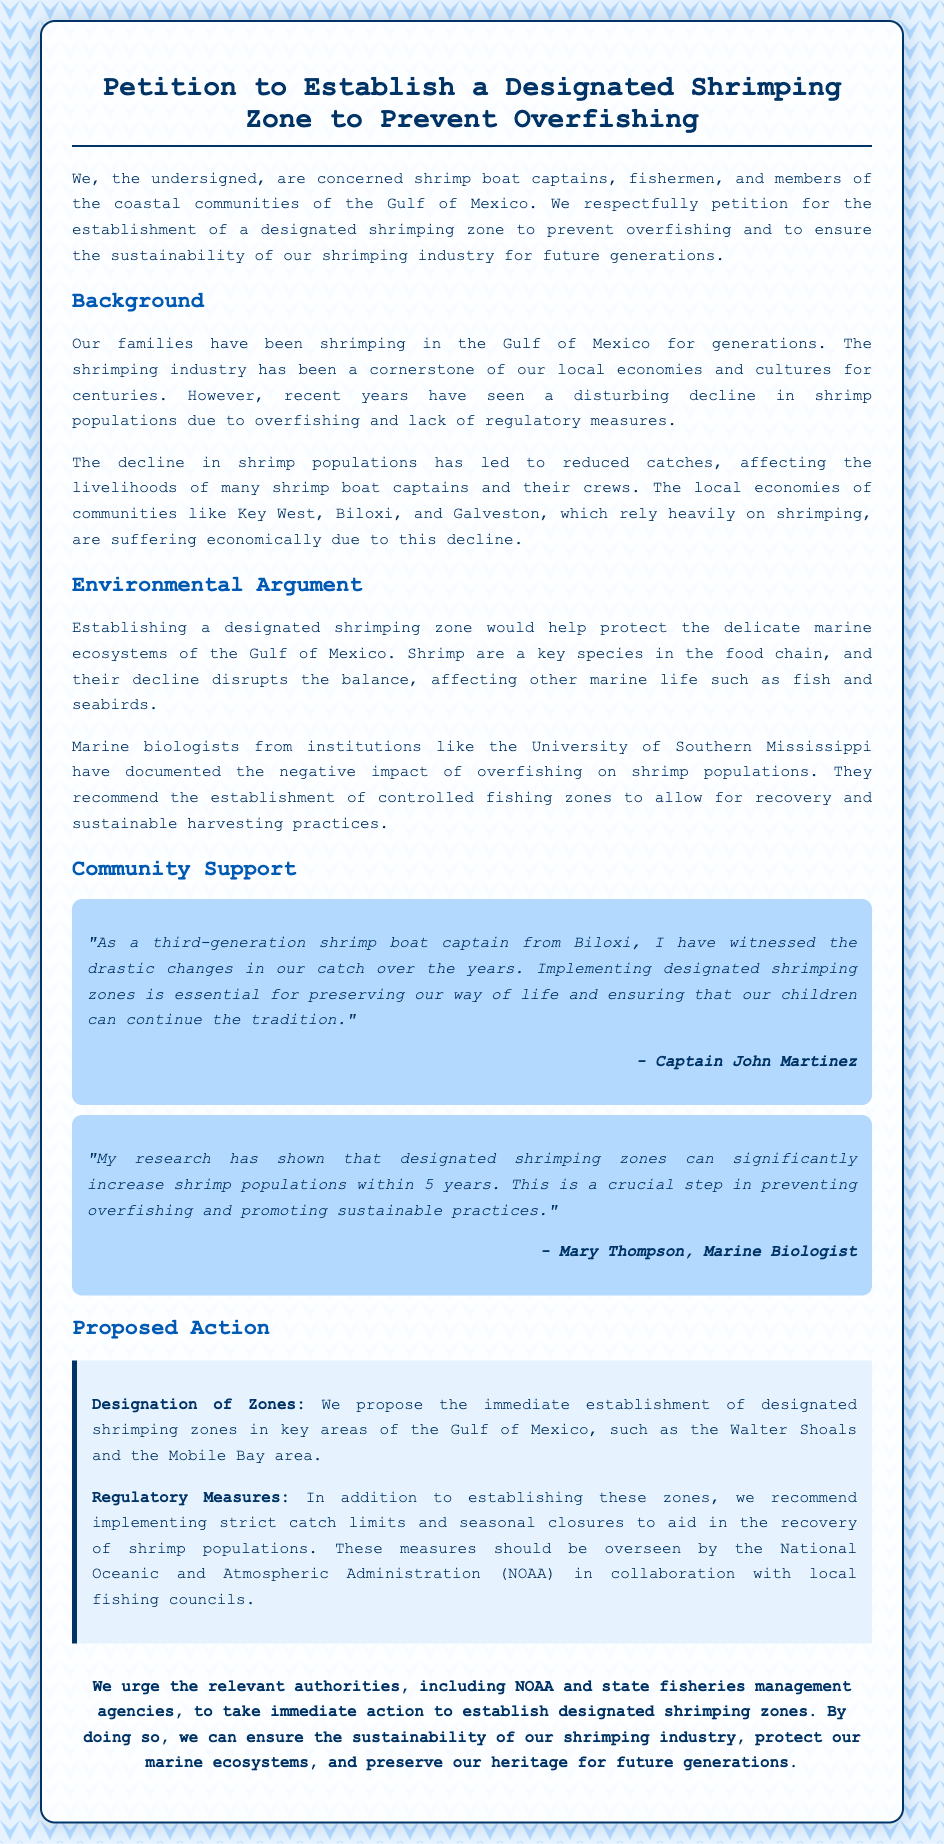What is the title of the petition? The title of the petition is specified at the top of the document, indicating its purpose.
Answer: Petition to Establish a Designated Shrimping Zone to Prevent Overfishing Who is the petition primarily addressed to? The petition is directed towards relevant authorities, specifically mentioning one agency.
Answer: NOAA What is the main environmental concern mentioned? The document highlights a critical issue impacting shrimp populations and marine life.
Answer: Overfishing What is the proposed location for designated shrimping zones? The petition suggests a specific area within the Gulf of Mexico for these zones.
Answer: Walter Shoals and the Mobile Bay area What is the profession of Captain John Martinez? The document includes testimonials that introduce individuals and their occupations.
Answer: Shrimp boat captain How long do marine biologists estimate it will take for shrimp populations to increase in designated zones? The document provides a timeframe related to the positive outcomes of proposed actions.
Answer: 5 years What type of industry is at risk according to the petition? The document specifies the type of industry that could be affected if no action is taken.
Answer: Shrimping industry What recommendation does the petition make regarding catch limits? The petition lists specific actions to support the recovery of shrimp populations within designated zones.
Answer: Implementing strict catch limits Who contributed a testimonial about the significance of designated shrimping zones? The document includes individuals providing their perspectives and research findings.
Answer: Mary Thompson, Marine Biologist 